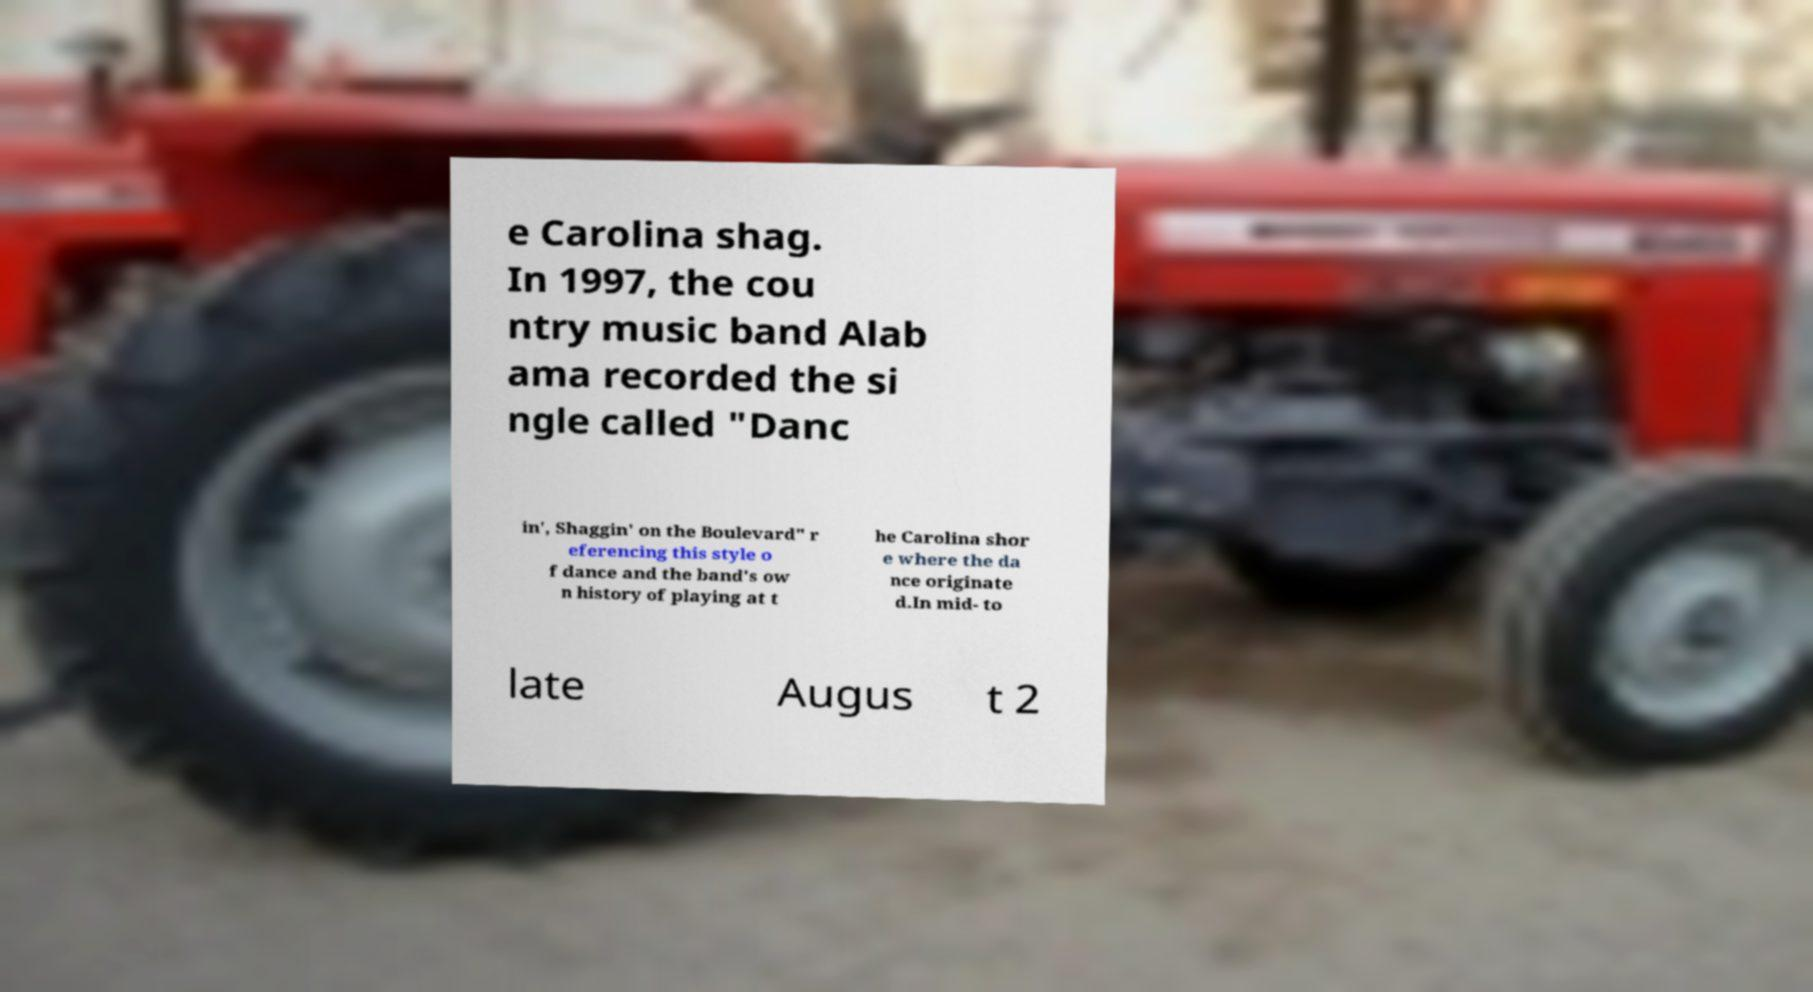I need the written content from this picture converted into text. Can you do that? e Carolina shag. In 1997, the cou ntry music band Alab ama recorded the si ngle called "Danc in', Shaggin' on the Boulevard" r eferencing this style o f dance and the band's ow n history of playing at t he Carolina shor e where the da nce originate d.In mid- to late Augus t 2 